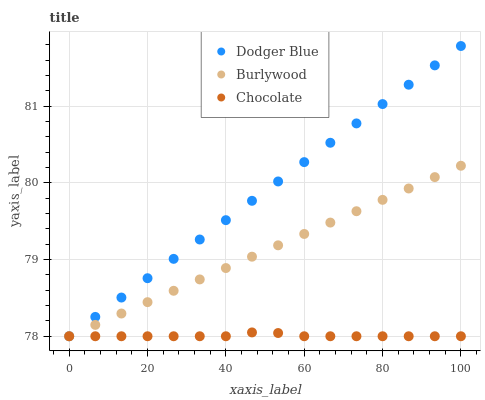Does Chocolate have the minimum area under the curve?
Answer yes or no. Yes. Does Dodger Blue have the maximum area under the curve?
Answer yes or no. Yes. Does Dodger Blue have the minimum area under the curve?
Answer yes or no. No. Does Chocolate have the maximum area under the curve?
Answer yes or no. No. Is Dodger Blue the smoothest?
Answer yes or no. Yes. Is Chocolate the roughest?
Answer yes or no. Yes. Is Chocolate the smoothest?
Answer yes or no. No. Is Dodger Blue the roughest?
Answer yes or no. No. Does Burlywood have the lowest value?
Answer yes or no. Yes. Does Dodger Blue have the highest value?
Answer yes or no. Yes. Does Chocolate have the highest value?
Answer yes or no. No. Does Chocolate intersect Dodger Blue?
Answer yes or no. Yes. Is Chocolate less than Dodger Blue?
Answer yes or no. No. Is Chocolate greater than Dodger Blue?
Answer yes or no. No. 